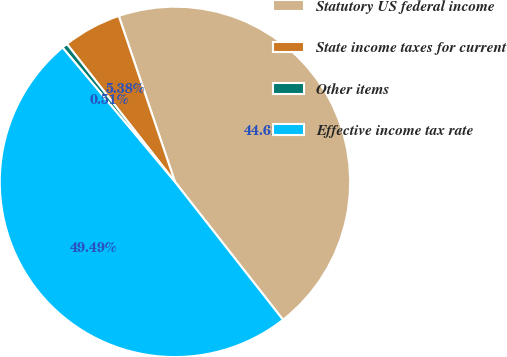Convert chart. <chart><loc_0><loc_0><loc_500><loc_500><pie_chart><fcel>Statutory US federal income<fcel>State income taxes for current<fcel>Other items<fcel>Effective income tax rate<nl><fcel>44.62%<fcel>5.38%<fcel>0.51%<fcel>49.49%<nl></chart> 